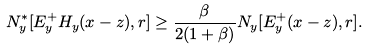<formula> <loc_0><loc_0><loc_500><loc_500>N _ { y } ^ { * } [ E _ { y } ^ { + } H _ { y } ( x - z ) , r ] \geq \frac { \beta } { 2 ( 1 + \beta ) } N _ { y } [ E _ { y } ^ { + } ( x - z ) , r ] .</formula> 